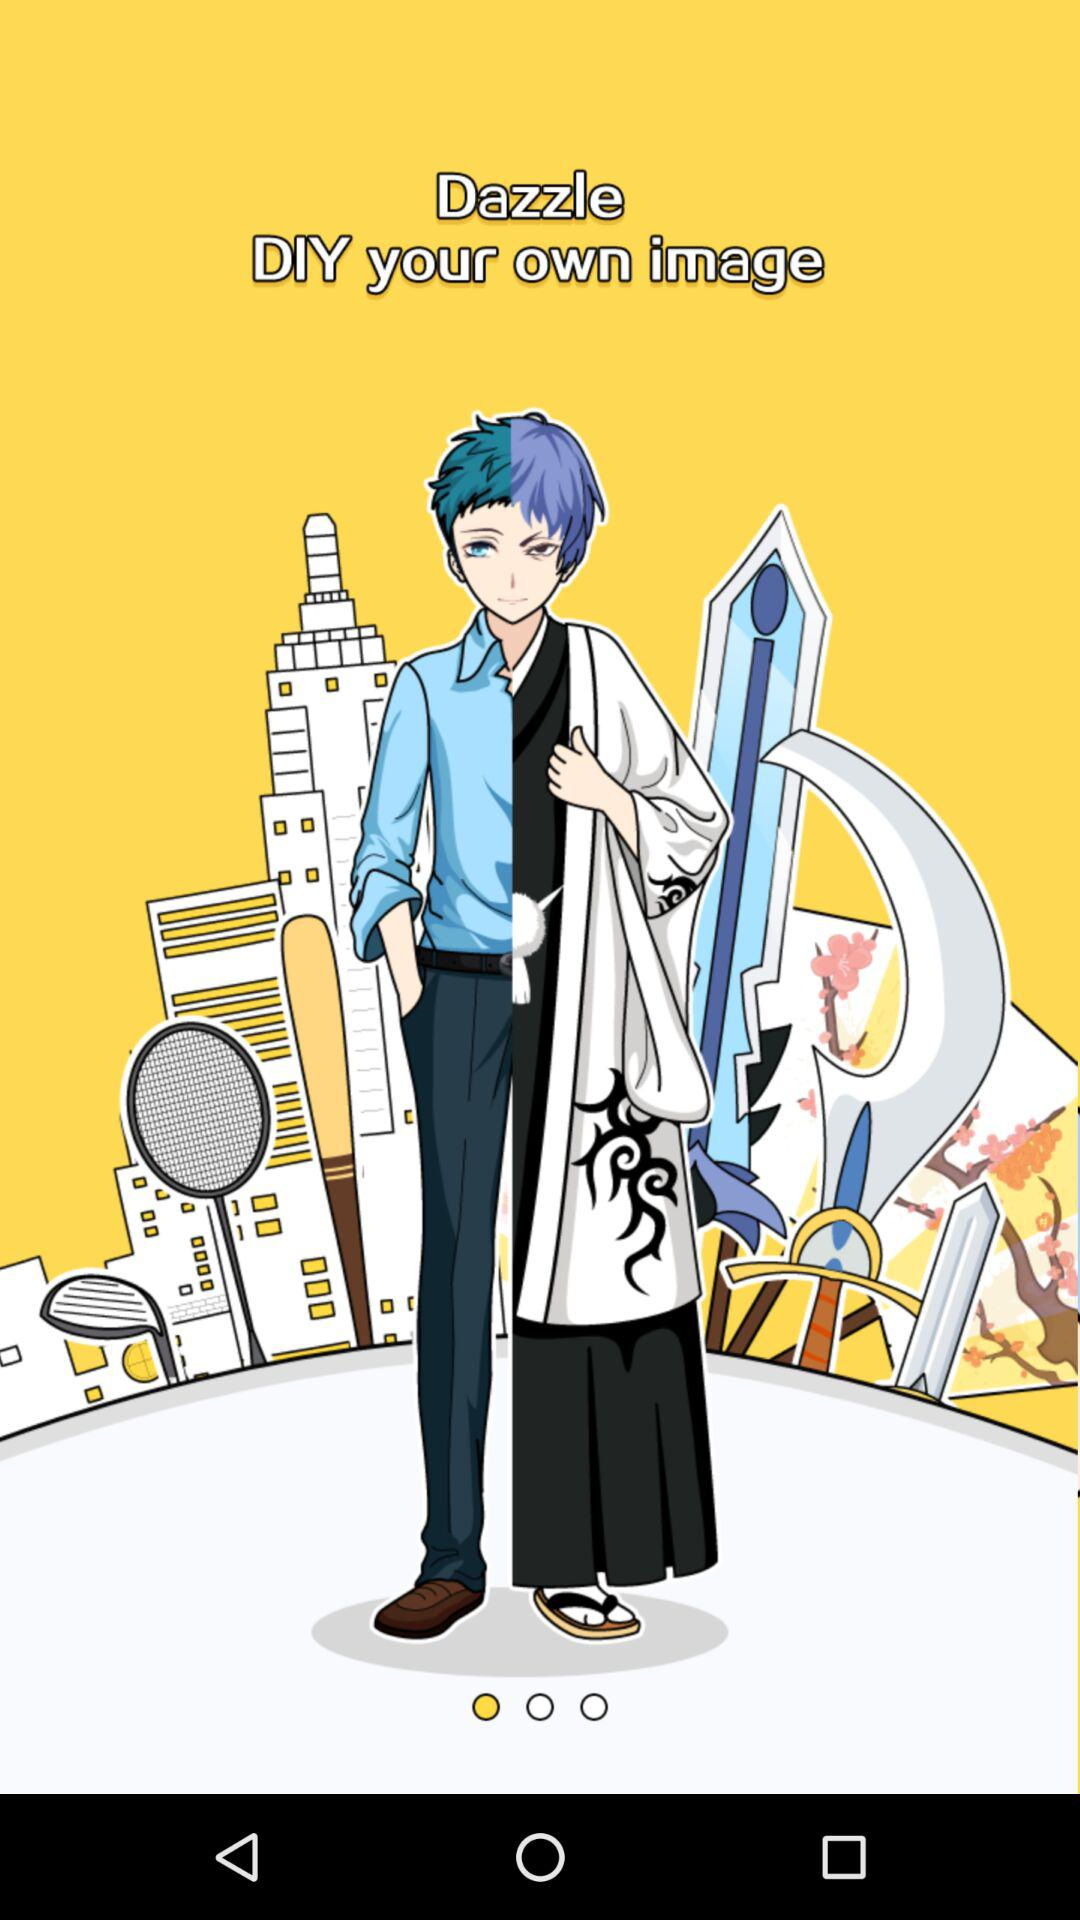What is the name of the application? The name of the application is "Dazzle". 